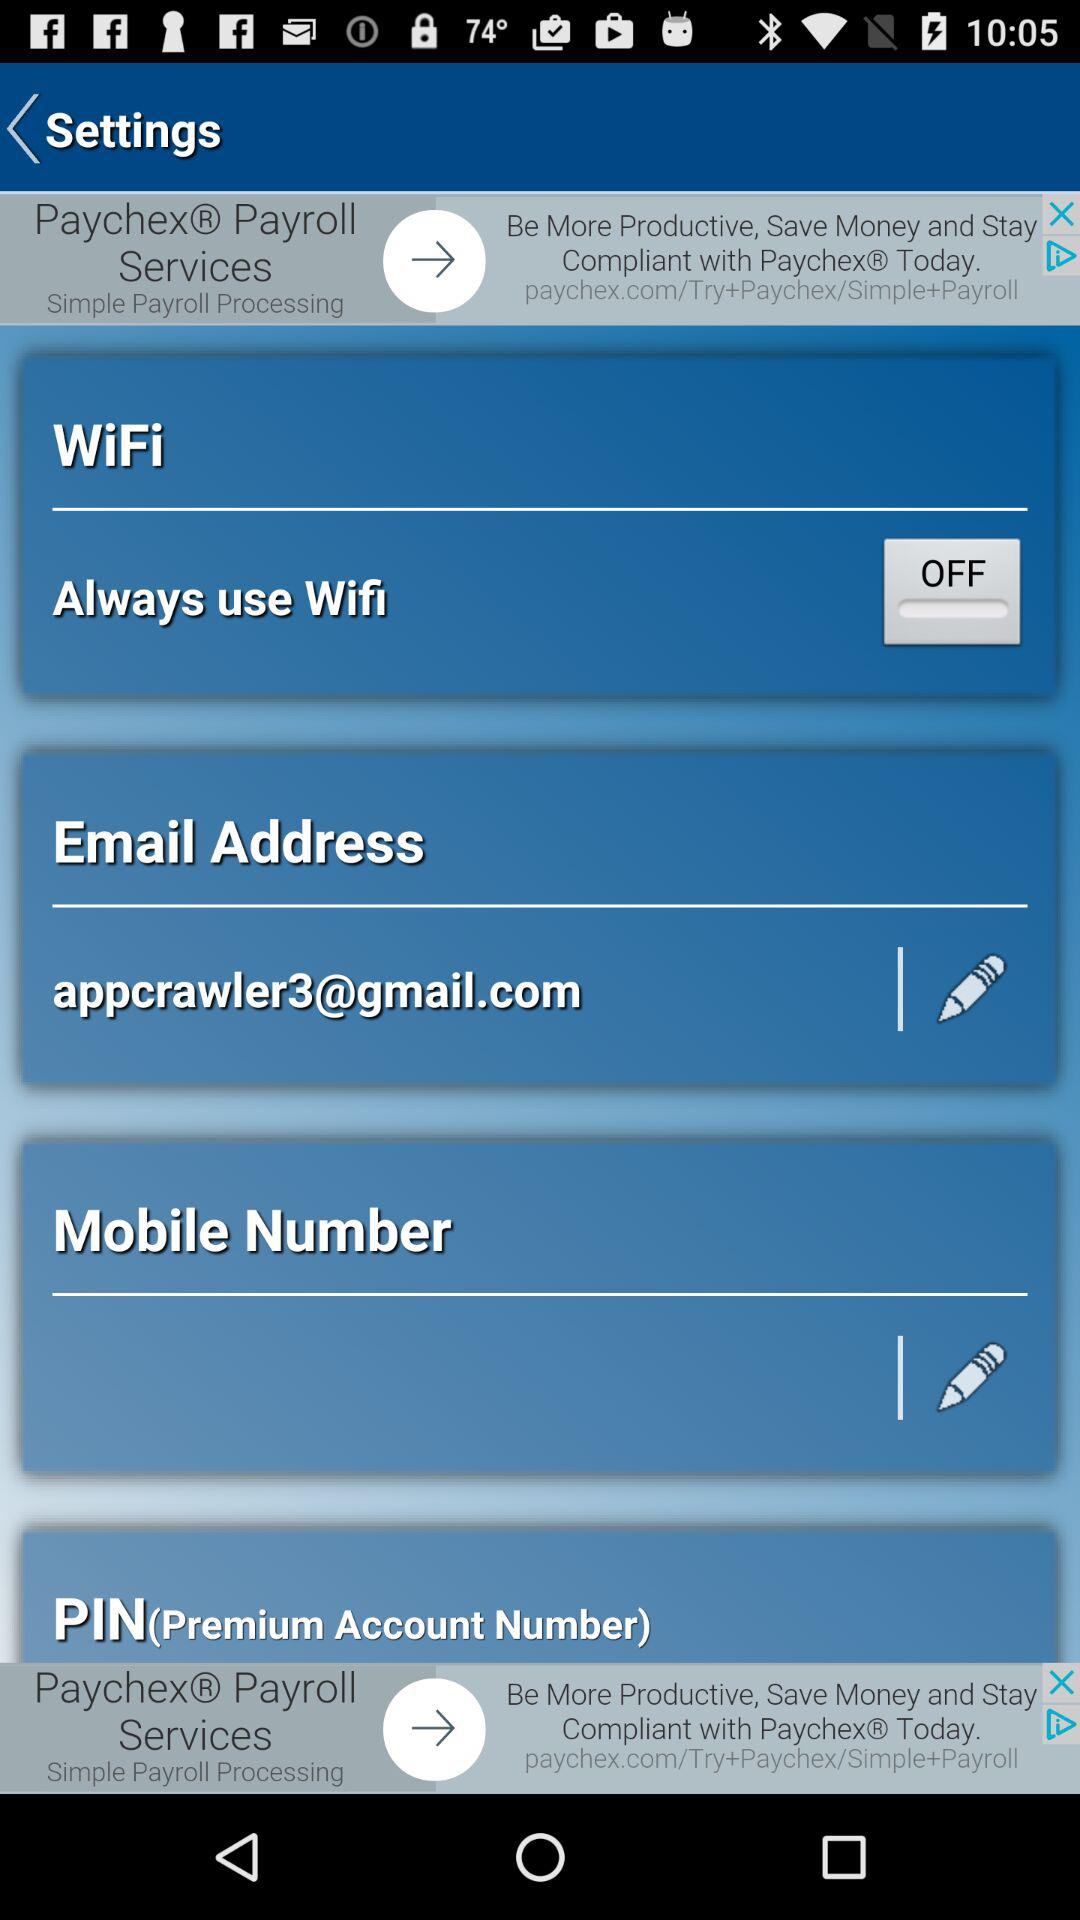What is the status of "Always use Wifi"? The status of "Always use Wifi" is "off". 